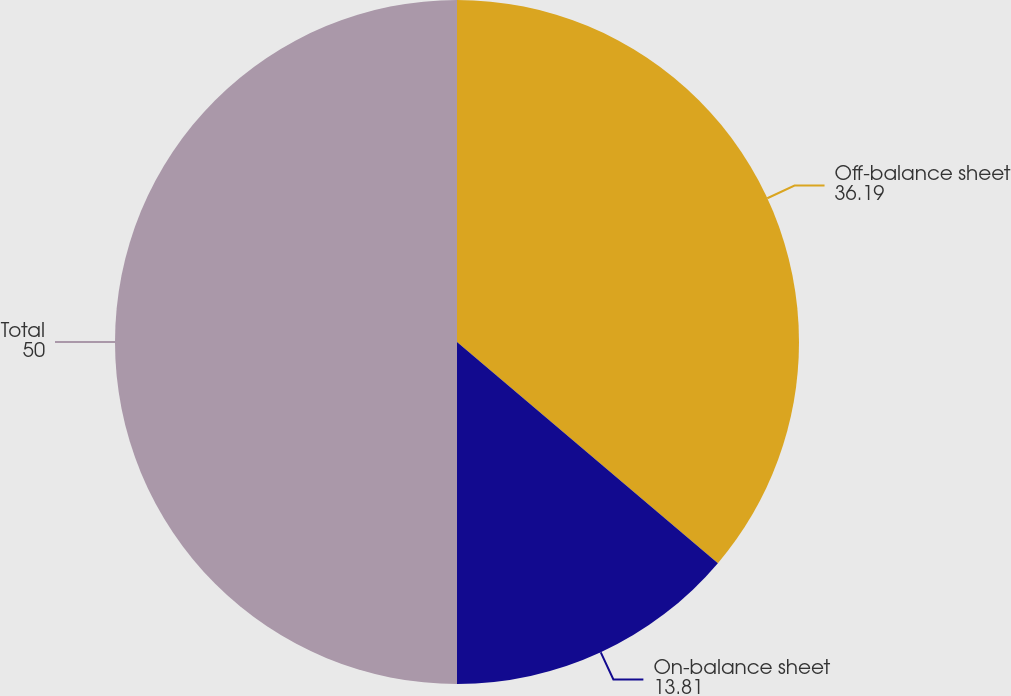Convert chart to OTSL. <chart><loc_0><loc_0><loc_500><loc_500><pie_chart><fcel>Off-balance sheet<fcel>On-balance sheet<fcel>Total<nl><fcel>36.19%<fcel>13.81%<fcel>50.0%<nl></chart> 